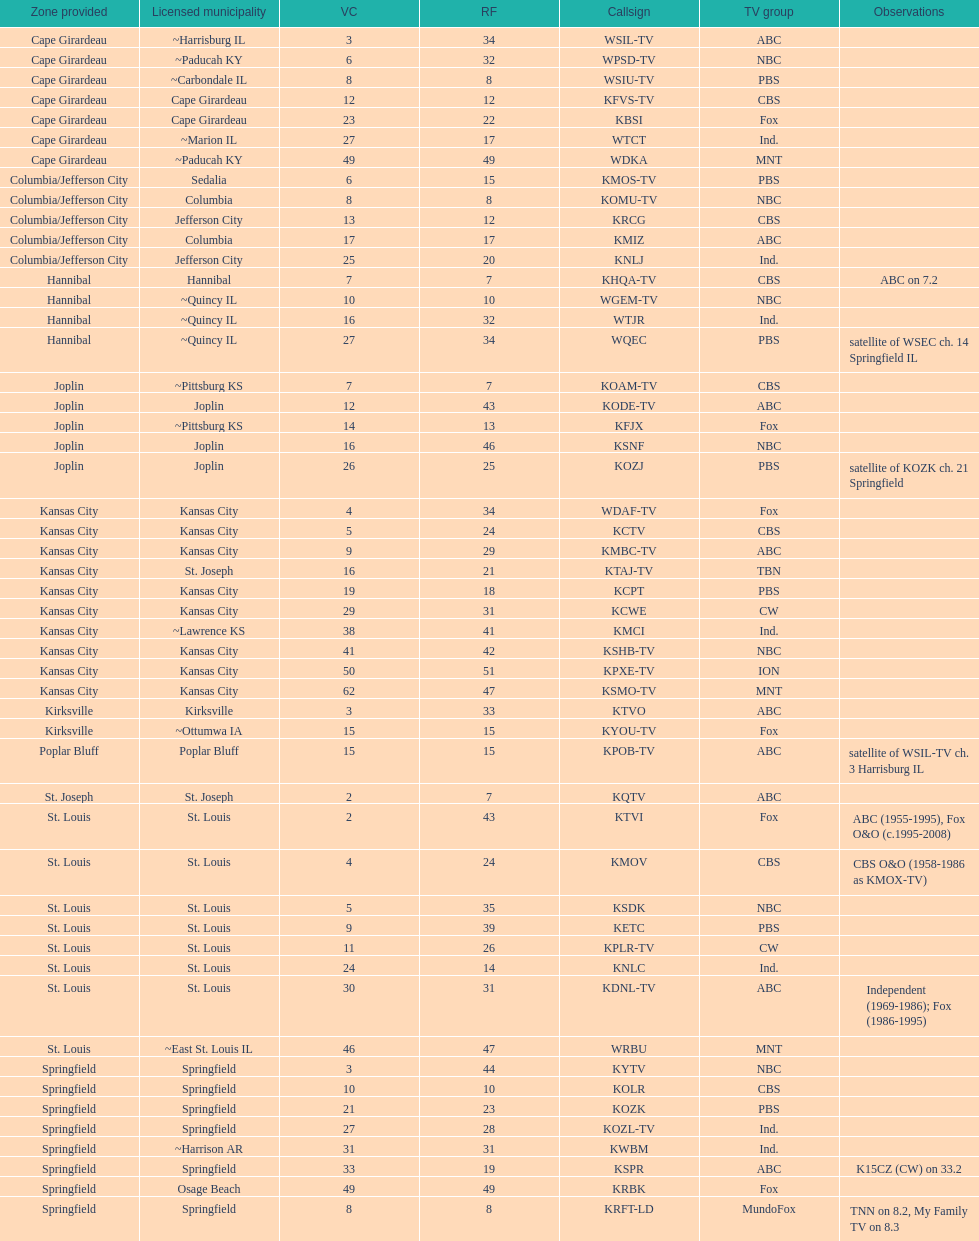What is the total number of stations serving the the cape girardeau area? 7. 